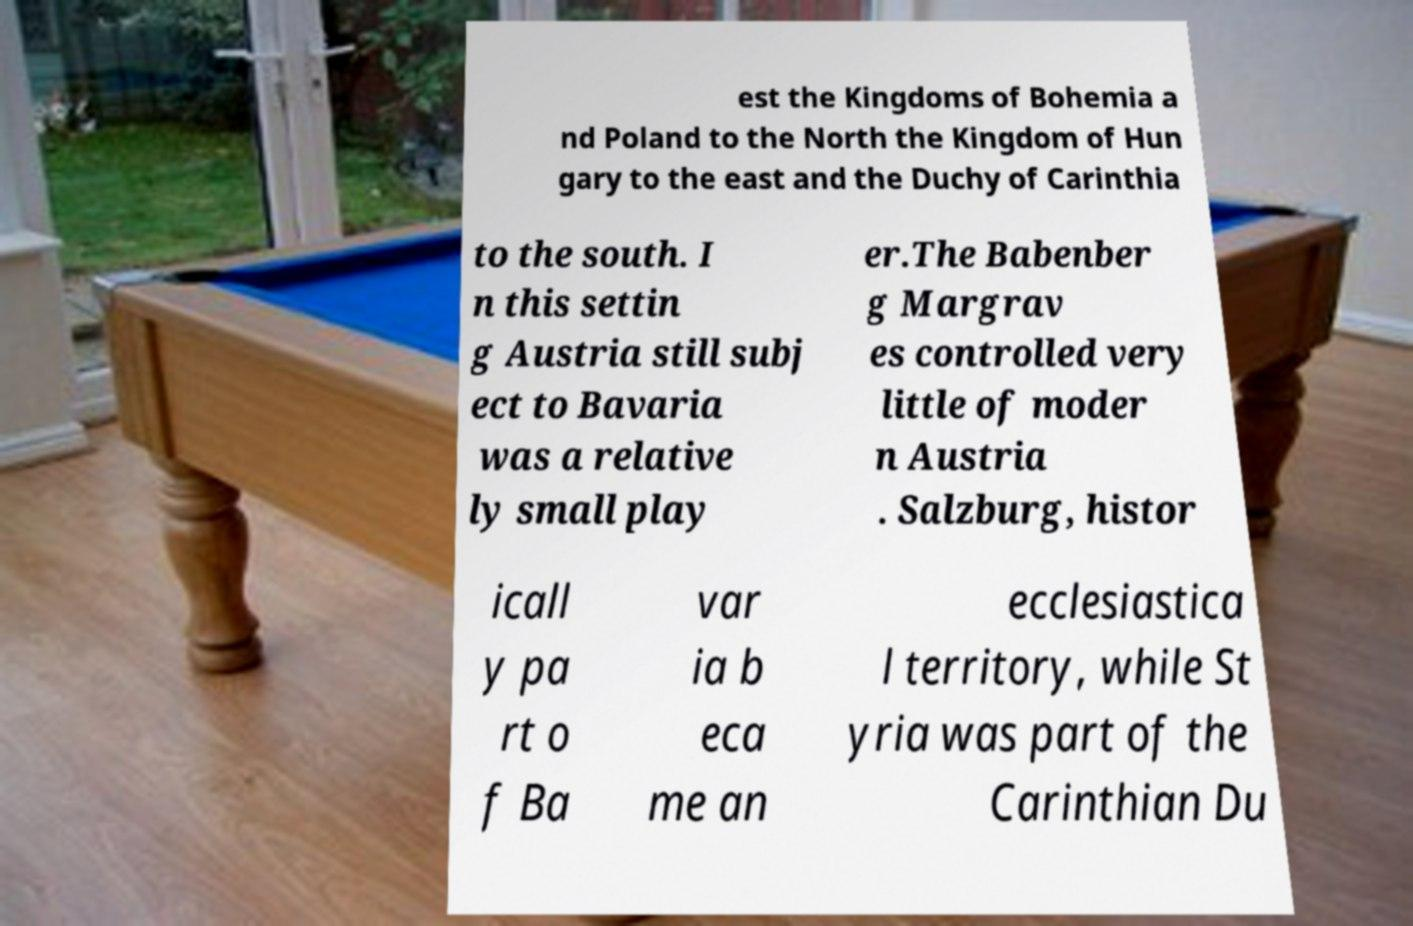I need the written content from this picture converted into text. Can you do that? est the Kingdoms of Bohemia a nd Poland to the North the Kingdom of Hun gary to the east and the Duchy of Carinthia to the south. I n this settin g Austria still subj ect to Bavaria was a relative ly small play er.The Babenber g Margrav es controlled very little of moder n Austria . Salzburg, histor icall y pa rt o f Ba var ia b eca me an ecclesiastica l territory, while St yria was part of the Carinthian Du 